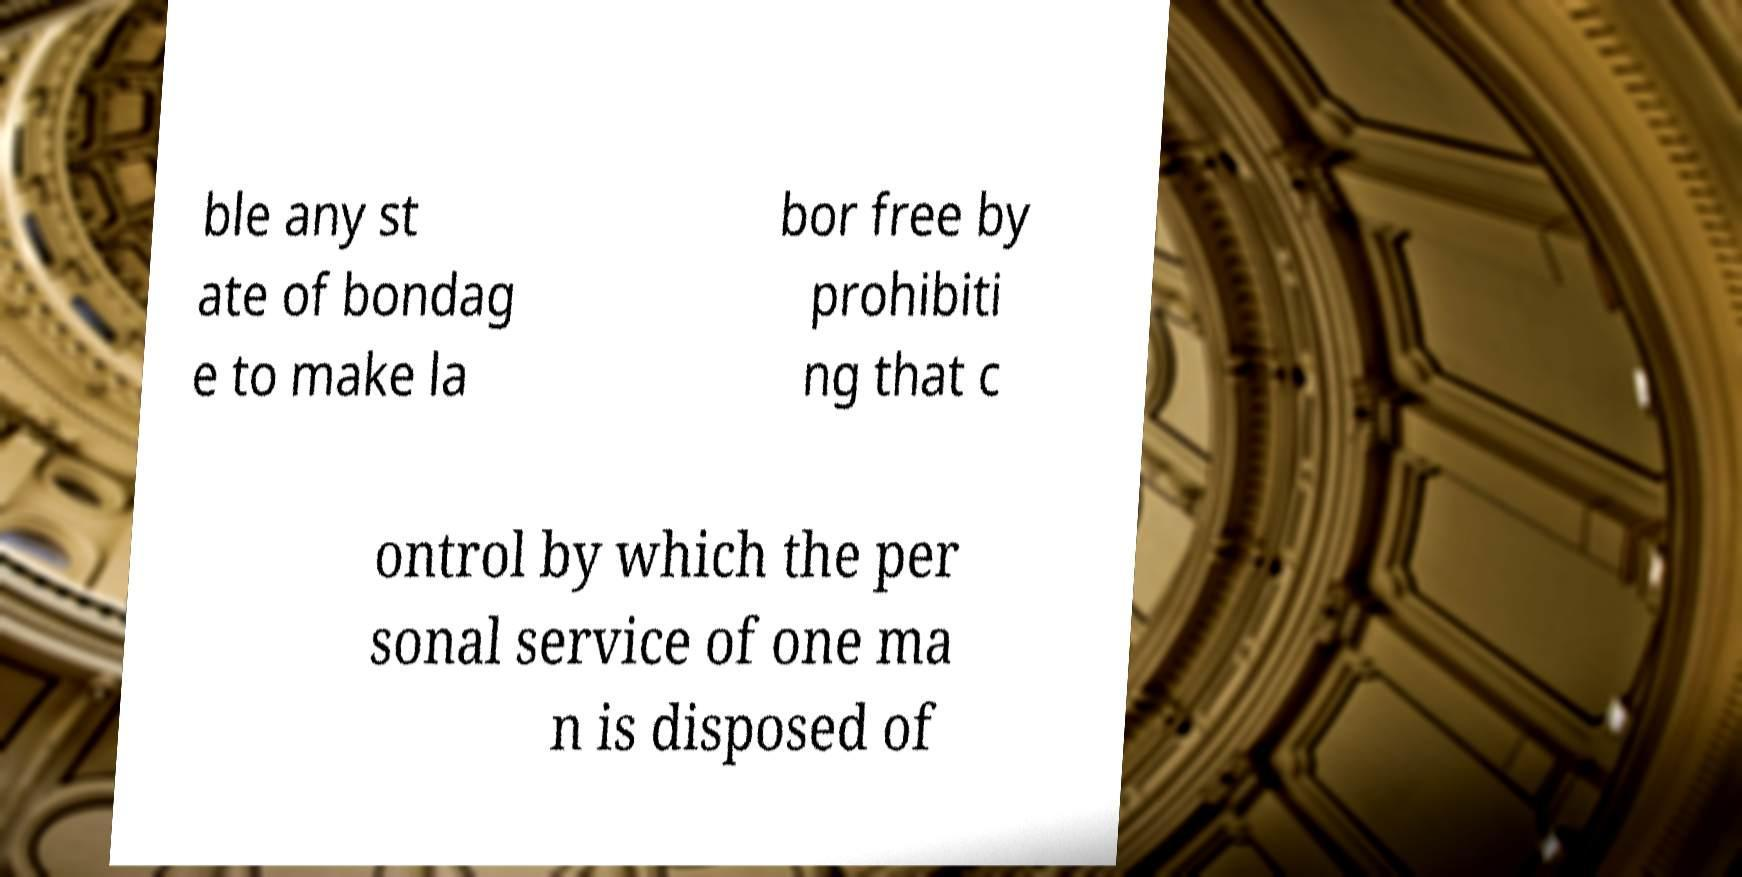Can you accurately transcribe the text from the provided image for me? ble any st ate of bondag e to make la bor free by prohibiti ng that c ontrol by which the per sonal service of one ma n is disposed of 